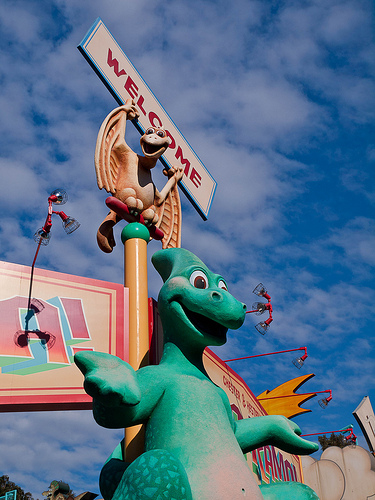<image>
Is there a dragon on the dinosaur? No. The dragon is not positioned on the dinosaur. They may be near each other, but the dragon is not supported by or resting on top of the dinosaur. Is the one in front of the two? No. The one is not in front of the two. The spatial positioning shows a different relationship between these objects. 